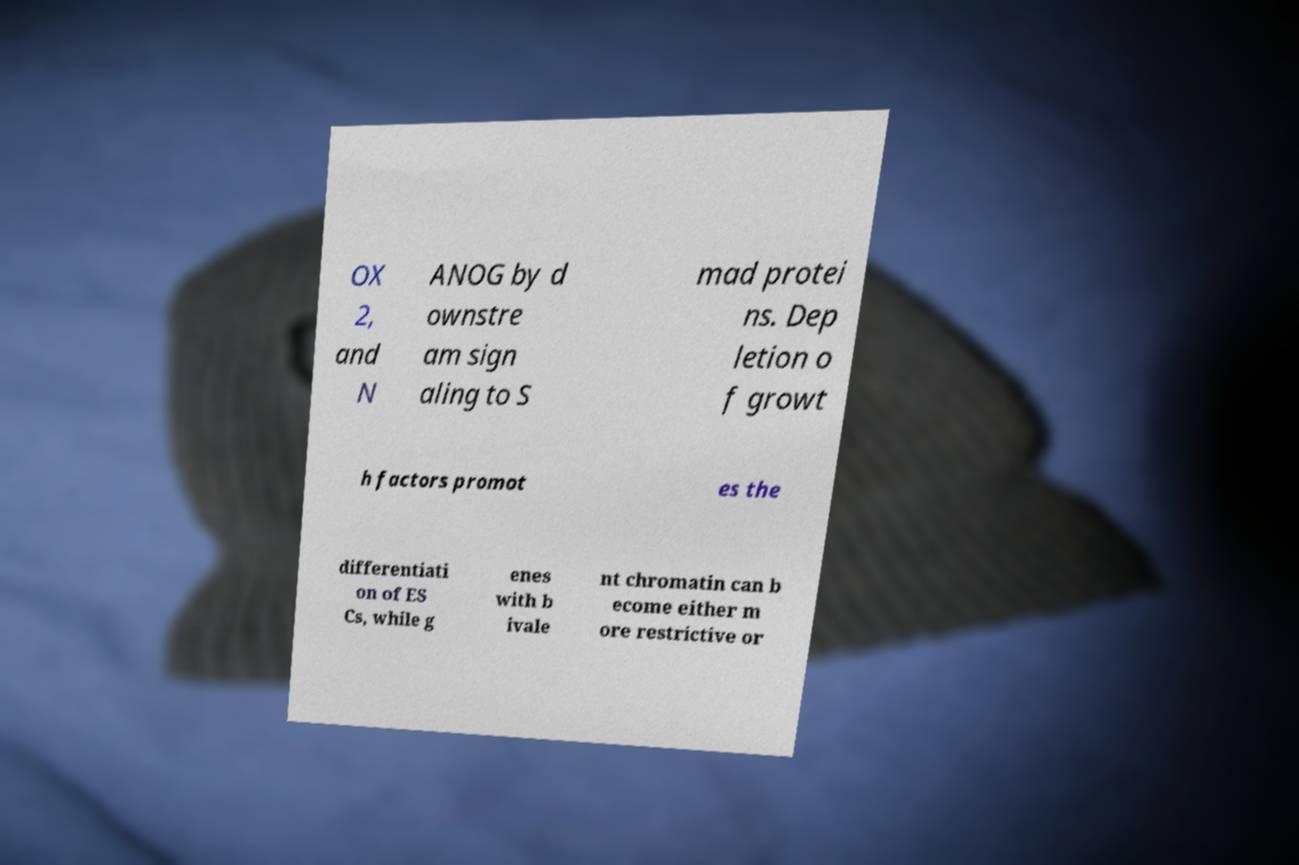Please read and relay the text visible in this image. What does it say? OX 2, and N ANOG by d ownstre am sign aling to S mad protei ns. Dep letion o f growt h factors promot es the differentiati on of ES Cs, while g enes with b ivale nt chromatin can b ecome either m ore restrictive or 